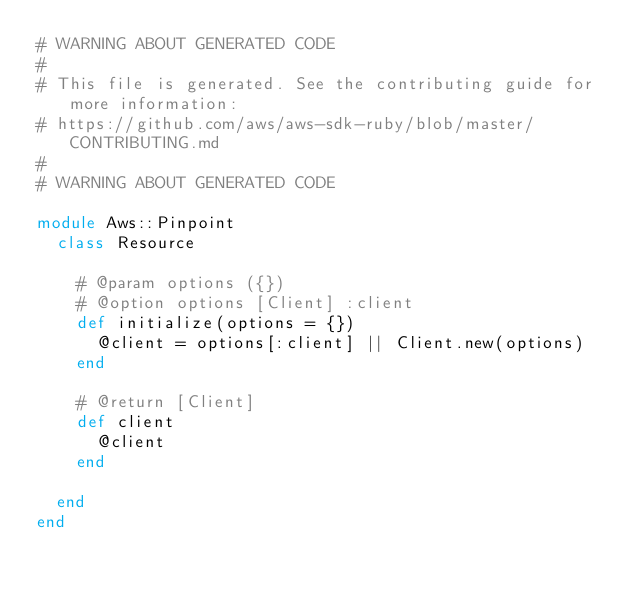<code> <loc_0><loc_0><loc_500><loc_500><_Ruby_># WARNING ABOUT GENERATED CODE
#
# This file is generated. See the contributing guide for more information:
# https://github.com/aws/aws-sdk-ruby/blob/master/CONTRIBUTING.md
#
# WARNING ABOUT GENERATED CODE

module Aws::Pinpoint
  class Resource

    # @param options ({})
    # @option options [Client] :client
    def initialize(options = {})
      @client = options[:client] || Client.new(options)
    end

    # @return [Client]
    def client
      @client
    end

  end
end
</code> 